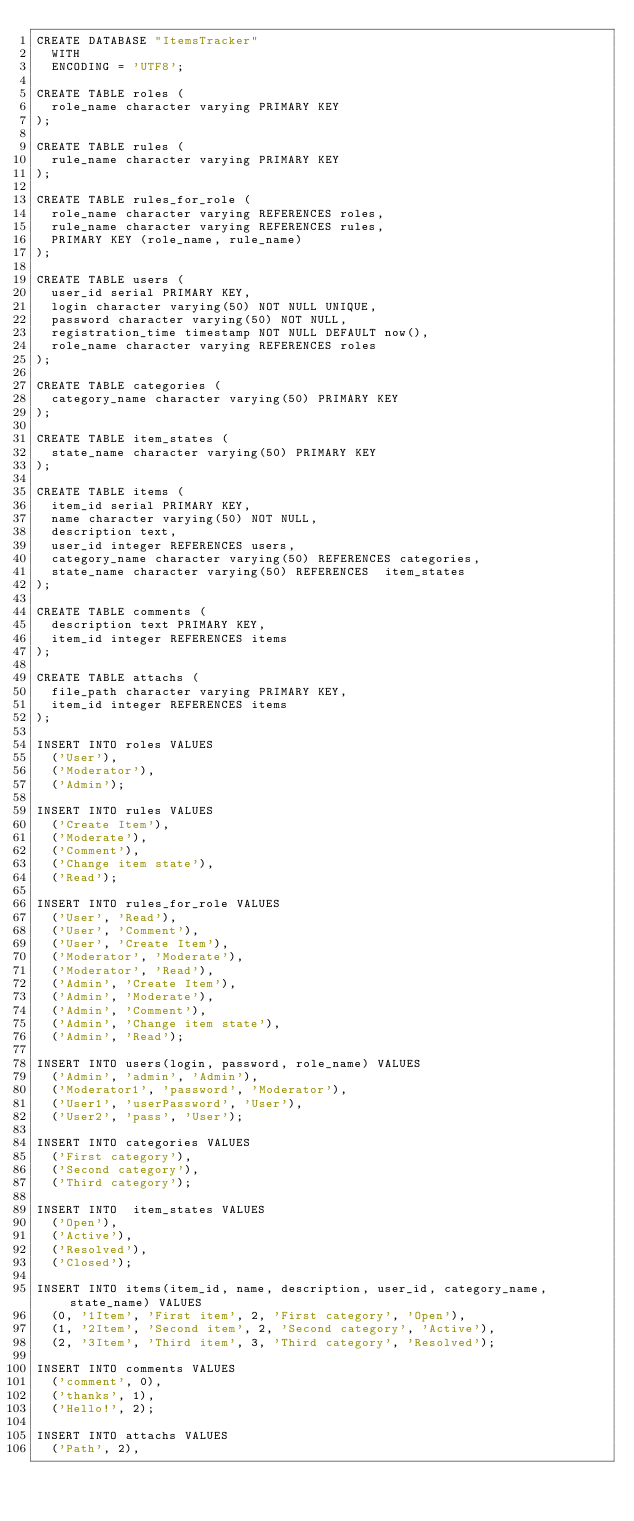Convert code to text. <code><loc_0><loc_0><loc_500><loc_500><_SQL_>CREATE DATABASE "ItemsTracker"
  WITH
  ENCODING = 'UTF8';

CREATE TABLE roles (
  role_name character varying PRIMARY KEY
);

CREATE TABLE rules (
  rule_name character varying PRIMARY KEY
);

CREATE TABLE rules_for_role (
  role_name character varying REFERENCES roles,
  rule_name character varying REFERENCES rules,
  PRIMARY KEY (role_name, rule_name)
);

CREATE TABLE users (
  user_id serial PRIMARY KEY,
  login character varying(50) NOT NULL UNIQUE,
  password character varying(50) NOT NULL,
  registration_time timestamp NOT NULL DEFAULT now(),
  role_name character varying REFERENCES roles
);

CREATE TABLE categories (
  category_name character varying(50) PRIMARY KEY
);

CREATE TABLE item_states (
  state_name character varying(50) PRIMARY KEY
);

CREATE TABLE items (
  item_id serial PRIMARY KEY,
  name character varying(50) NOT NULL,
  description text,
  user_id integer REFERENCES users,
  category_name character varying(50) REFERENCES categories,
  state_name character varying(50) REFERENCES  item_states
);

CREATE TABLE comments (
  description text PRIMARY KEY,
  item_id integer REFERENCES items
);

CREATE TABLE attachs (
  file_path character varying PRIMARY KEY,
  item_id integer REFERENCES items
);

INSERT INTO roles VALUES
  ('User'),
  ('Moderator'),
  ('Admin');

INSERT INTO rules VALUES
  ('Create Item'),
  ('Moderate'),
  ('Comment'),
  ('Change item state'),
  ('Read');

INSERT INTO rules_for_role VALUES
  ('User', 'Read'),
  ('User', 'Comment'),
  ('User', 'Create Item'),
  ('Moderator', 'Moderate'),
  ('Moderator', 'Read'),
  ('Admin', 'Create Item'),
  ('Admin', 'Moderate'),
  ('Admin', 'Comment'),
  ('Admin', 'Change item state'),
  ('Admin', 'Read');

INSERT INTO users(login, password, role_name) VALUES
  ('Admin', 'admin', 'Admin'),
  ('Moderator1', 'password', 'Moderator'),
  ('User1', 'userPassword', 'User'),
  ('User2', 'pass', 'User');

INSERT INTO categories VALUES
  ('First category'),
  ('Second category'),
  ('Third category');

INSERT INTO  item_states VALUES
  ('Open'),
  ('Active'),
  ('Resolved'),
  ('Closed');

INSERT INTO items(item_id, name, description, user_id, category_name, state_name) VALUES
  (0, '1Item', 'First item', 2, 'First category', 'Open'),
  (1, '2Item', 'Second item', 2, 'Second category', 'Active'),
  (2, '3Item', 'Third item', 3, 'Third category', 'Resolved');

INSERT INTO comments VALUES
  ('comment', 0),
  ('thanks', 1),
  ('Hello!', 2);

INSERT INTO attachs VALUES
  ('Path', 2),</code> 